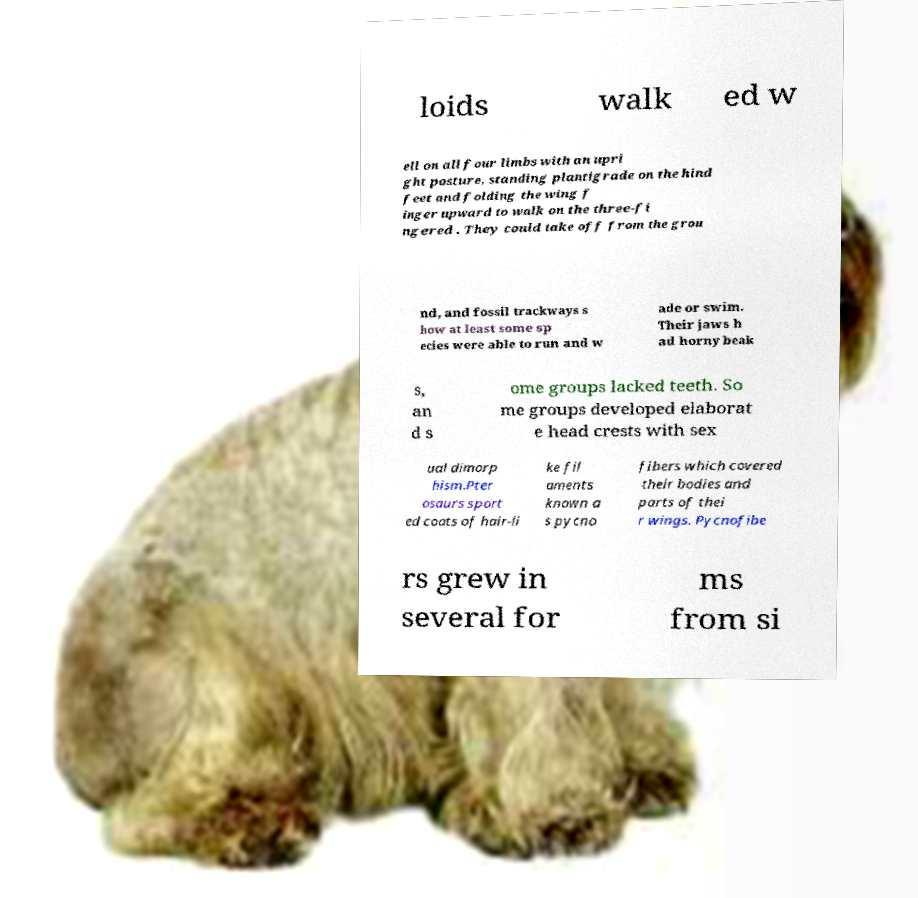I need the written content from this picture converted into text. Can you do that? loids walk ed w ell on all four limbs with an upri ght posture, standing plantigrade on the hind feet and folding the wing f inger upward to walk on the three-fi ngered . They could take off from the grou nd, and fossil trackways s how at least some sp ecies were able to run and w ade or swim. Their jaws h ad horny beak s, an d s ome groups lacked teeth. So me groups developed elaborat e head crests with sex ual dimorp hism.Pter osaurs sport ed coats of hair-li ke fil aments known a s pycno fibers which covered their bodies and parts of thei r wings. Pycnofibe rs grew in several for ms from si 